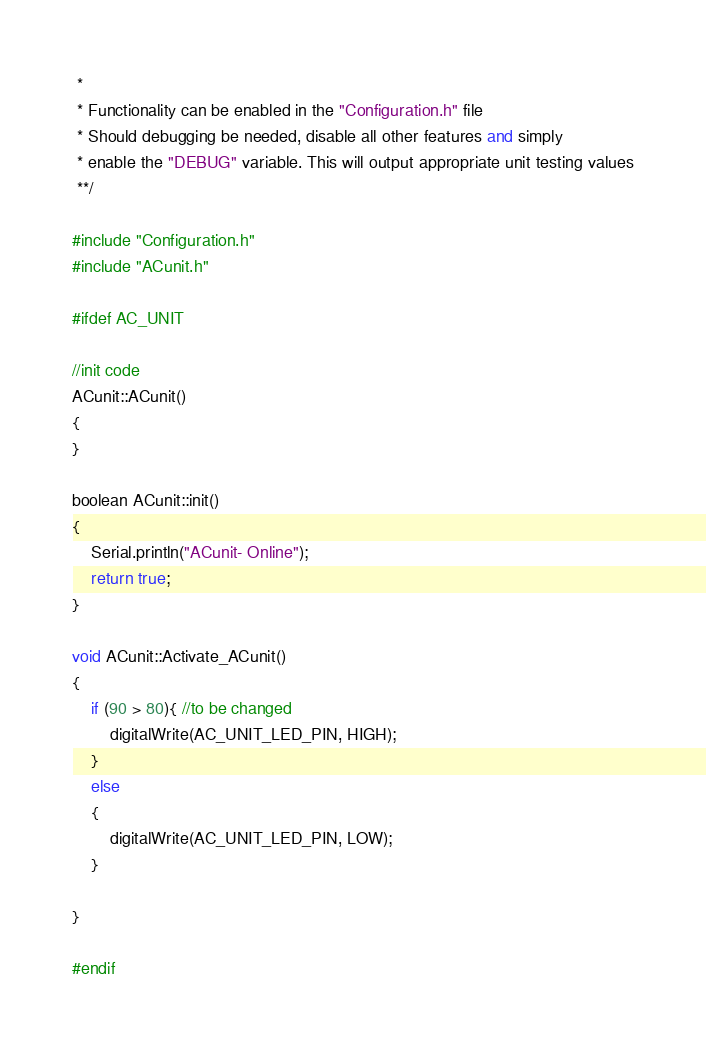Convert code to text. <code><loc_0><loc_0><loc_500><loc_500><_C++_> * 
 * Functionality can be enabled in the "Configuration.h" file
 * Should debugging be needed, disable all other features and simply
 * enable the "DEBUG" variable. This will output appropriate unit testing values
 **/

#include "Configuration.h"
#include "ACunit.h"

#ifdef AC_UNIT

//init code
ACunit::ACunit()
{
}

boolean ACunit::init()
{
    Serial.println("ACunit- Online");
    return true;
}

void ACunit::Activate_ACunit()
{
    if (90 > 80){ //to be changed
        digitalWrite(AC_UNIT_LED_PIN, HIGH);
    }
    else 
    {
        digitalWrite(AC_UNIT_LED_PIN, LOW);
    }

}

#endif</code> 